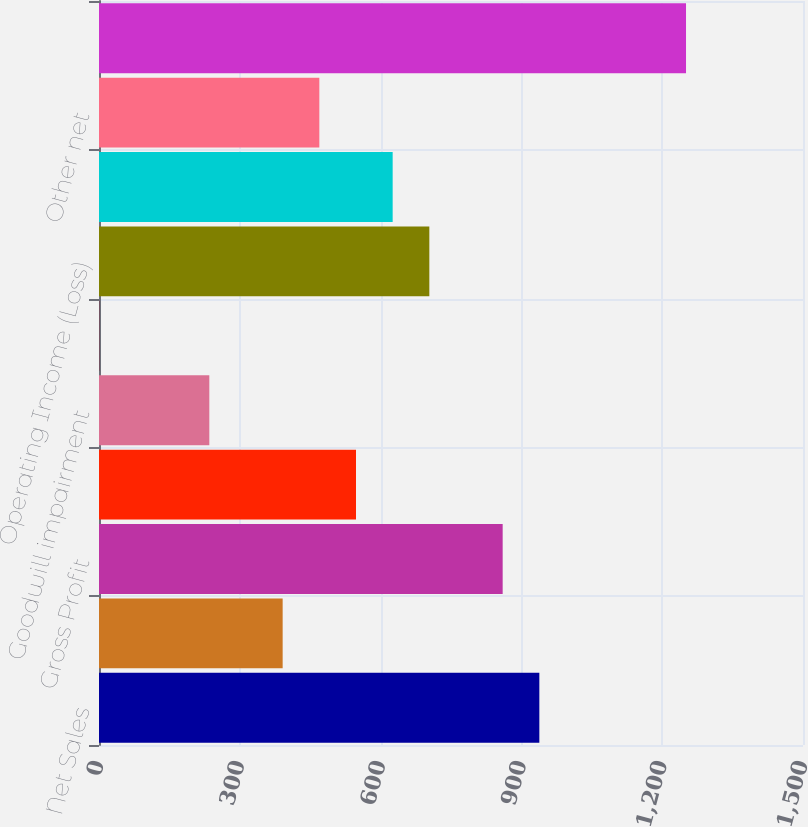<chart> <loc_0><loc_0><loc_500><loc_500><bar_chart><fcel>Net Sales<fcel>Cost of Sales<fcel>Gross Profit<fcel>Selling general and<fcel>Goodwill impairment<fcel>Other charges<fcel>Operating Income (Loss)<fcel>Interest expense net<fcel>Other net<fcel>Equity in net earnings of<nl><fcel>938.23<fcel>391.32<fcel>860.1<fcel>547.58<fcel>235.06<fcel>0.67<fcel>703.84<fcel>625.71<fcel>469.45<fcel>1250.75<nl></chart> 